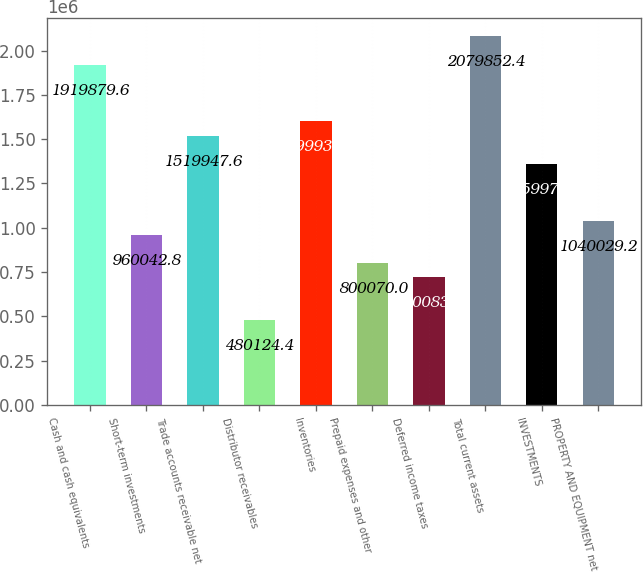Convert chart to OTSL. <chart><loc_0><loc_0><loc_500><loc_500><bar_chart><fcel>Cash and cash equivalents<fcel>Short-term investments<fcel>Trade accounts receivable net<fcel>Distributor receivables<fcel>Inventories<fcel>Prepaid expenses and other<fcel>Deferred income taxes<fcel>Total current assets<fcel>INVESTMENTS<fcel>PROPERTY AND EQUIPMENT net<nl><fcel>1.91988e+06<fcel>960043<fcel>1.51995e+06<fcel>480124<fcel>1.59993e+06<fcel>800070<fcel>720084<fcel>2.07985e+06<fcel>1.35997e+06<fcel>1.04003e+06<nl></chart> 